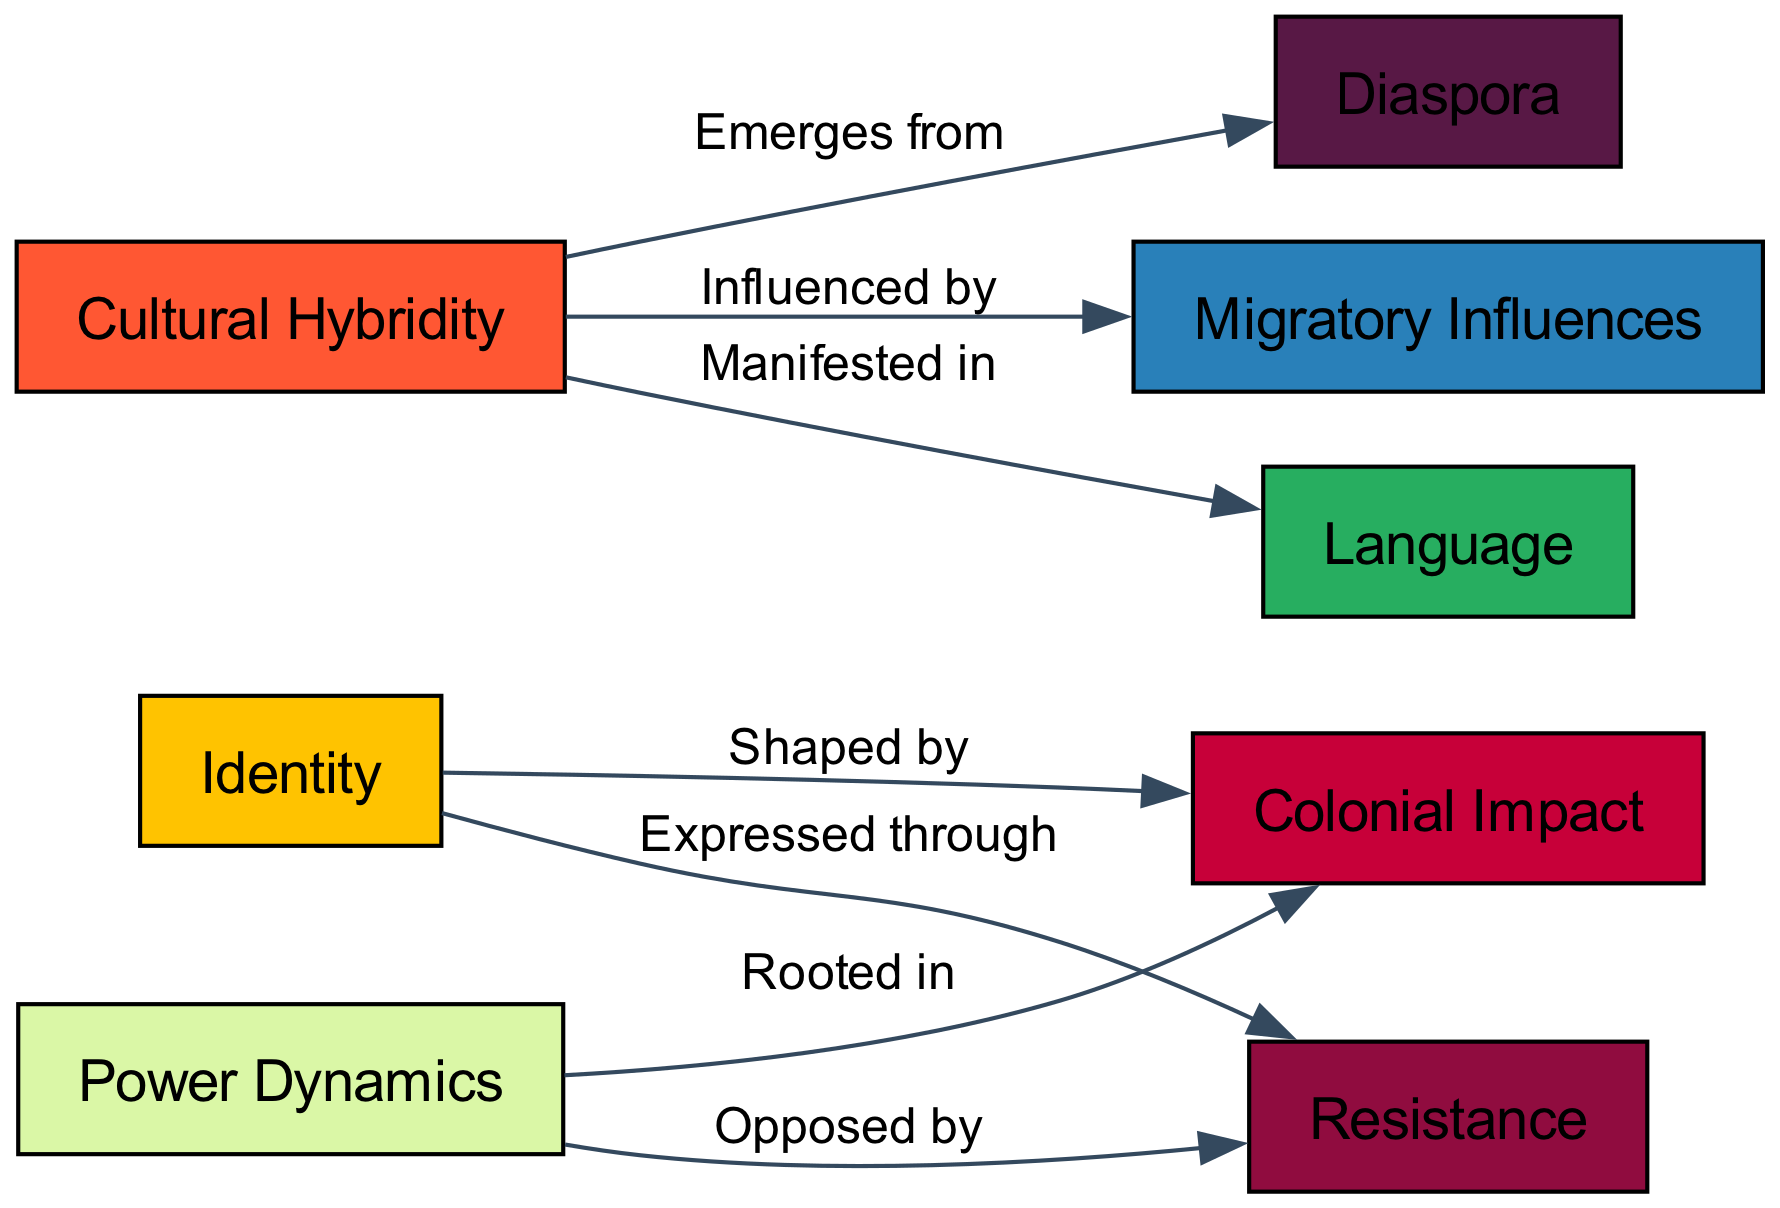What are the three main themes in postcolonial theater depicted in the diagram? The diagram identifies three main themes: Identity, Power Dynamics, and Cultural Hybridity, which are represented as nodes.
Answer: Identity, Power Dynamics, Cultural Hybridity How many nodes are represented in the diagram? By counting the entries in the "nodes" section of the provided data, we find that there are eight nodes in total.
Answer: 8 What does the node "Identity" express through? The diagram indicates that Identity is expressed through Resistance, as shown by the directed edge labeled "Expressed through" connecting these nodes.
Answer: Resistance Which theme is influenced by Migratory Influences? The diagram clearly shows that Cultural Hybridity is influenced by Migratory Influences as stated in the edge relationship.
Answer: Cultural Hybridity What is Colonial Impact rooted in? According to the diagram, Power Dynamics is rooted in Colonial Impact, confirmed by the edge labeled "Rooted in" connecting both concepts.
Answer: Power Dynamics How does Cultural Hybridity manifest in the diagram? The diagram specifies that Cultural Hybridity is manifested in Language; this is depicted with the directed edge labeled "Manifested in."
Answer: Language What relationships involve the theme of "Resistance"? The theme of Resistance is involved in two relationships: it is expressed through Identity and opposed by Power Dynamics, represented by the respective edges linking them.
Answer: Identity, Power Dynamics What theme emerges from Diaspora? The diagram indicates that Cultural Hybridity emerges from Diaspora, as highlighted by the edge labeled "Emerges from."
Answer: Cultural Hybridity 